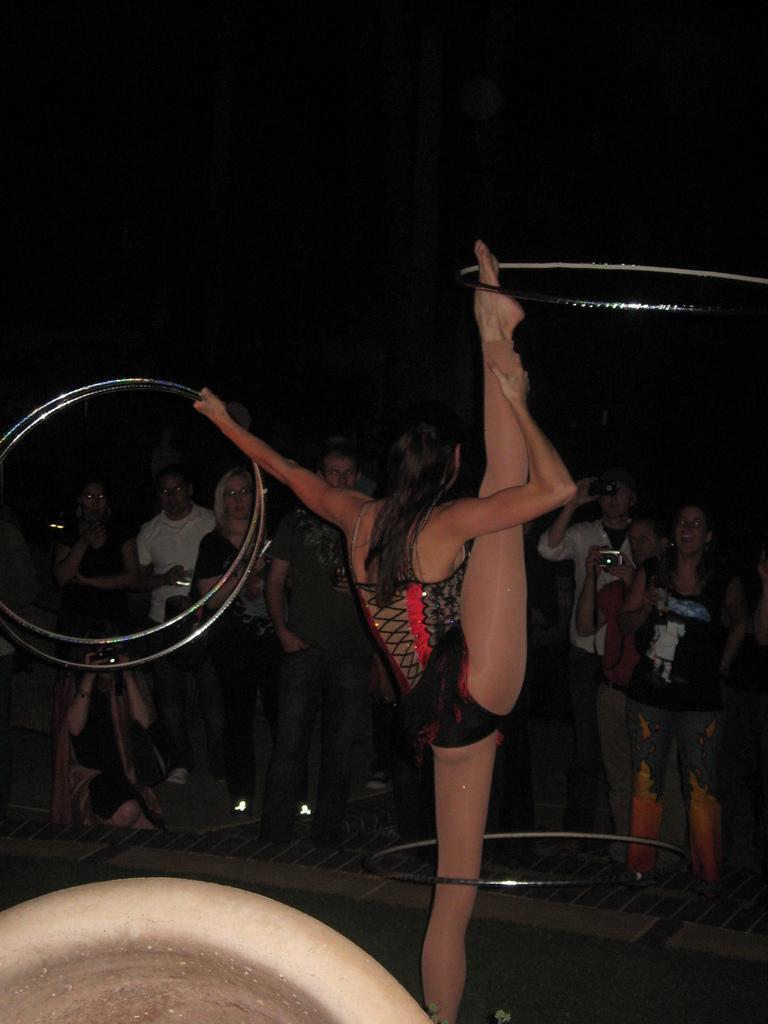Please provide a concise description of this image. In the middle of the image a woman is standing and holding rings. Behind her few people are standing and holding cameras and watching. 